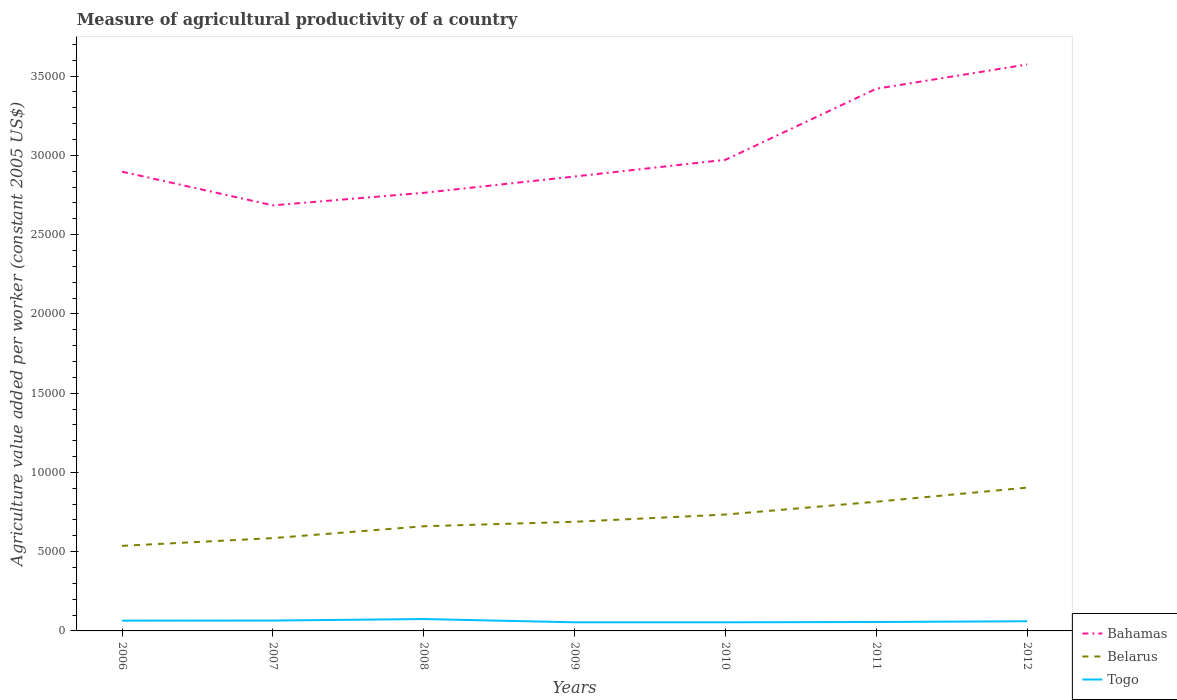Does the line corresponding to Belarus intersect with the line corresponding to Bahamas?
Make the answer very short. No. Is the number of lines equal to the number of legend labels?
Offer a terse response. Yes. Across all years, what is the maximum measure of agricultural productivity in Togo?
Make the answer very short. 543.73. What is the total measure of agricultural productivity in Togo in the graph?
Ensure brevity in your answer.  -0.05. What is the difference between the highest and the second highest measure of agricultural productivity in Togo?
Give a very brief answer. 205.68. What is the difference between the highest and the lowest measure of agricultural productivity in Belarus?
Your answer should be compact. 3. Is the measure of agricultural productivity in Bahamas strictly greater than the measure of agricultural productivity in Togo over the years?
Keep it short and to the point. No. What is the difference between two consecutive major ticks on the Y-axis?
Offer a very short reply. 5000. Does the graph contain any zero values?
Offer a terse response. No. What is the title of the graph?
Provide a short and direct response. Measure of agricultural productivity of a country. Does "Papua New Guinea" appear as one of the legend labels in the graph?
Keep it short and to the point. No. What is the label or title of the Y-axis?
Your response must be concise. Agriculture value added per worker (constant 2005 US$). What is the Agriculture value added per worker (constant 2005 US$) in Bahamas in 2006?
Provide a short and direct response. 2.90e+04. What is the Agriculture value added per worker (constant 2005 US$) in Belarus in 2006?
Your answer should be compact. 5366.93. What is the Agriculture value added per worker (constant 2005 US$) in Togo in 2006?
Give a very brief answer. 648.93. What is the Agriculture value added per worker (constant 2005 US$) in Bahamas in 2007?
Ensure brevity in your answer.  2.68e+04. What is the Agriculture value added per worker (constant 2005 US$) in Belarus in 2007?
Provide a succinct answer. 5855.35. What is the Agriculture value added per worker (constant 2005 US$) in Togo in 2007?
Provide a short and direct response. 654.09. What is the Agriculture value added per worker (constant 2005 US$) in Bahamas in 2008?
Give a very brief answer. 2.76e+04. What is the Agriculture value added per worker (constant 2005 US$) of Belarus in 2008?
Offer a very short reply. 6602.84. What is the Agriculture value added per worker (constant 2005 US$) in Togo in 2008?
Your answer should be compact. 749.41. What is the Agriculture value added per worker (constant 2005 US$) in Bahamas in 2009?
Ensure brevity in your answer.  2.87e+04. What is the Agriculture value added per worker (constant 2005 US$) in Belarus in 2009?
Your answer should be very brief. 6885.24. What is the Agriculture value added per worker (constant 2005 US$) in Togo in 2009?
Make the answer very short. 543.73. What is the Agriculture value added per worker (constant 2005 US$) of Bahamas in 2010?
Offer a very short reply. 2.97e+04. What is the Agriculture value added per worker (constant 2005 US$) of Belarus in 2010?
Your response must be concise. 7341.49. What is the Agriculture value added per worker (constant 2005 US$) in Togo in 2010?
Offer a very short reply. 543.78. What is the Agriculture value added per worker (constant 2005 US$) in Bahamas in 2011?
Your answer should be compact. 3.42e+04. What is the Agriculture value added per worker (constant 2005 US$) in Belarus in 2011?
Offer a terse response. 8150.77. What is the Agriculture value added per worker (constant 2005 US$) in Togo in 2011?
Offer a terse response. 562.64. What is the Agriculture value added per worker (constant 2005 US$) of Bahamas in 2012?
Your answer should be compact. 3.57e+04. What is the Agriculture value added per worker (constant 2005 US$) of Belarus in 2012?
Provide a short and direct response. 9040.6. What is the Agriculture value added per worker (constant 2005 US$) of Togo in 2012?
Keep it short and to the point. 610.53. Across all years, what is the maximum Agriculture value added per worker (constant 2005 US$) in Bahamas?
Your response must be concise. 3.57e+04. Across all years, what is the maximum Agriculture value added per worker (constant 2005 US$) in Belarus?
Give a very brief answer. 9040.6. Across all years, what is the maximum Agriculture value added per worker (constant 2005 US$) in Togo?
Your answer should be compact. 749.41. Across all years, what is the minimum Agriculture value added per worker (constant 2005 US$) in Bahamas?
Your answer should be very brief. 2.68e+04. Across all years, what is the minimum Agriculture value added per worker (constant 2005 US$) in Belarus?
Your response must be concise. 5366.93. Across all years, what is the minimum Agriculture value added per worker (constant 2005 US$) of Togo?
Ensure brevity in your answer.  543.73. What is the total Agriculture value added per worker (constant 2005 US$) of Bahamas in the graph?
Your answer should be compact. 2.12e+05. What is the total Agriculture value added per worker (constant 2005 US$) in Belarus in the graph?
Give a very brief answer. 4.92e+04. What is the total Agriculture value added per worker (constant 2005 US$) of Togo in the graph?
Provide a short and direct response. 4313.11. What is the difference between the Agriculture value added per worker (constant 2005 US$) of Bahamas in 2006 and that in 2007?
Offer a terse response. 2124.79. What is the difference between the Agriculture value added per worker (constant 2005 US$) of Belarus in 2006 and that in 2007?
Make the answer very short. -488.42. What is the difference between the Agriculture value added per worker (constant 2005 US$) of Togo in 2006 and that in 2007?
Provide a short and direct response. -5.15. What is the difference between the Agriculture value added per worker (constant 2005 US$) of Bahamas in 2006 and that in 2008?
Give a very brief answer. 1333.73. What is the difference between the Agriculture value added per worker (constant 2005 US$) of Belarus in 2006 and that in 2008?
Your answer should be compact. -1235.91. What is the difference between the Agriculture value added per worker (constant 2005 US$) of Togo in 2006 and that in 2008?
Your answer should be very brief. -100.47. What is the difference between the Agriculture value added per worker (constant 2005 US$) in Bahamas in 2006 and that in 2009?
Ensure brevity in your answer.  303.45. What is the difference between the Agriculture value added per worker (constant 2005 US$) of Belarus in 2006 and that in 2009?
Keep it short and to the point. -1518.31. What is the difference between the Agriculture value added per worker (constant 2005 US$) in Togo in 2006 and that in 2009?
Your response must be concise. 105.21. What is the difference between the Agriculture value added per worker (constant 2005 US$) of Bahamas in 2006 and that in 2010?
Give a very brief answer. -749.95. What is the difference between the Agriculture value added per worker (constant 2005 US$) in Belarus in 2006 and that in 2010?
Provide a short and direct response. -1974.57. What is the difference between the Agriculture value added per worker (constant 2005 US$) of Togo in 2006 and that in 2010?
Your answer should be compact. 105.15. What is the difference between the Agriculture value added per worker (constant 2005 US$) in Bahamas in 2006 and that in 2011?
Your response must be concise. -5231.33. What is the difference between the Agriculture value added per worker (constant 2005 US$) in Belarus in 2006 and that in 2011?
Make the answer very short. -2783.84. What is the difference between the Agriculture value added per worker (constant 2005 US$) in Togo in 2006 and that in 2011?
Your response must be concise. 86.29. What is the difference between the Agriculture value added per worker (constant 2005 US$) in Bahamas in 2006 and that in 2012?
Your answer should be very brief. -6763.83. What is the difference between the Agriculture value added per worker (constant 2005 US$) of Belarus in 2006 and that in 2012?
Your answer should be compact. -3673.67. What is the difference between the Agriculture value added per worker (constant 2005 US$) of Togo in 2006 and that in 2012?
Provide a succinct answer. 38.4. What is the difference between the Agriculture value added per worker (constant 2005 US$) in Bahamas in 2007 and that in 2008?
Provide a short and direct response. -791.06. What is the difference between the Agriculture value added per worker (constant 2005 US$) of Belarus in 2007 and that in 2008?
Make the answer very short. -747.49. What is the difference between the Agriculture value added per worker (constant 2005 US$) of Togo in 2007 and that in 2008?
Offer a terse response. -95.32. What is the difference between the Agriculture value added per worker (constant 2005 US$) of Bahamas in 2007 and that in 2009?
Keep it short and to the point. -1821.34. What is the difference between the Agriculture value added per worker (constant 2005 US$) in Belarus in 2007 and that in 2009?
Your response must be concise. -1029.89. What is the difference between the Agriculture value added per worker (constant 2005 US$) of Togo in 2007 and that in 2009?
Provide a succinct answer. 110.36. What is the difference between the Agriculture value added per worker (constant 2005 US$) of Bahamas in 2007 and that in 2010?
Your response must be concise. -2874.74. What is the difference between the Agriculture value added per worker (constant 2005 US$) in Belarus in 2007 and that in 2010?
Keep it short and to the point. -1486.14. What is the difference between the Agriculture value added per worker (constant 2005 US$) of Togo in 2007 and that in 2010?
Offer a very short reply. 110.3. What is the difference between the Agriculture value added per worker (constant 2005 US$) in Bahamas in 2007 and that in 2011?
Keep it short and to the point. -7356.12. What is the difference between the Agriculture value added per worker (constant 2005 US$) of Belarus in 2007 and that in 2011?
Keep it short and to the point. -2295.42. What is the difference between the Agriculture value added per worker (constant 2005 US$) in Togo in 2007 and that in 2011?
Keep it short and to the point. 91.44. What is the difference between the Agriculture value added per worker (constant 2005 US$) in Bahamas in 2007 and that in 2012?
Make the answer very short. -8888.62. What is the difference between the Agriculture value added per worker (constant 2005 US$) in Belarus in 2007 and that in 2012?
Your answer should be compact. -3185.25. What is the difference between the Agriculture value added per worker (constant 2005 US$) in Togo in 2007 and that in 2012?
Keep it short and to the point. 43.55. What is the difference between the Agriculture value added per worker (constant 2005 US$) of Bahamas in 2008 and that in 2009?
Ensure brevity in your answer.  -1030.28. What is the difference between the Agriculture value added per worker (constant 2005 US$) in Belarus in 2008 and that in 2009?
Offer a terse response. -282.4. What is the difference between the Agriculture value added per worker (constant 2005 US$) in Togo in 2008 and that in 2009?
Make the answer very short. 205.68. What is the difference between the Agriculture value added per worker (constant 2005 US$) in Bahamas in 2008 and that in 2010?
Your answer should be very brief. -2083.69. What is the difference between the Agriculture value added per worker (constant 2005 US$) in Belarus in 2008 and that in 2010?
Your answer should be compact. -738.65. What is the difference between the Agriculture value added per worker (constant 2005 US$) in Togo in 2008 and that in 2010?
Provide a succinct answer. 205.63. What is the difference between the Agriculture value added per worker (constant 2005 US$) of Bahamas in 2008 and that in 2011?
Your response must be concise. -6565.06. What is the difference between the Agriculture value added per worker (constant 2005 US$) in Belarus in 2008 and that in 2011?
Make the answer very short. -1547.93. What is the difference between the Agriculture value added per worker (constant 2005 US$) of Togo in 2008 and that in 2011?
Offer a very short reply. 186.76. What is the difference between the Agriculture value added per worker (constant 2005 US$) of Bahamas in 2008 and that in 2012?
Your answer should be compact. -8097.56. What is the difference between the Agriculture value added per worker (constant 2005 US$) in Belarus in 2008 and that in 2012?
Offer a terse response. -2437.76. What is the difference between the Agriculture value added per worker (constant 2005 US$) of Togo in 2008 and that in 2012?
Provide a short and direct response. 138.88. What is the difference between the Agriculture value added per worker (constant 2005 US$) in Bahamas in 2009 and that in 2010?
Offer a terse response. -1053.4. What is the difference between the Agriculture value added per worker (constant 2005 US$) of Belarus in 2009 and that in 2010?
Your answer should be compact. -456.25. What is the difference between the Agriculture value added per worker (constant 2005 US$) of Togo in 2009 and that in 2010?
Your answer should be compact. -0.06. What is the difference between the Agriculture value added per worker (constant 2005 US$) of Bahamas in 2009 and that in 2011?
Your response must be concise. -5534.78. What is the difference between the Agriculture value added per worker (constant 2005 US$) of Belarus in 2009 and that in 2011?
Your response must be concise. -1265.53. What is the difference between the Agriculture value added per worker (constant 2005 US$) of Togo in 2009 and that in 2011?
Give a very brief answer. -18.92. What is the difference between the Agriculture value added per worker (constant 2005 US$) of Bahamas in 2009 and that in 2012?
Your answer should be very brief. -7067.28. What is the difference between the Agriculture value added per worker (constant 2005 US$) in Belarus in 2009 and that in 2012?
Your answer should be very brief. -2155.36. What is the difference between the Agriculture value added per worker (constant 2005 US$) of Togo in 2009 and that in 2012?
Ensure brevity in your answer.  -66.8. What is the difference between the Agriculture value added per worker (constant 2005 US$) of Bahamas in 2010 and that in 2011?
Provide a succinct answer. -4481.38. What is the difference between the Agriculture value added per worker (constant 2005 US$) of Belarus in 2010 and that in 2011?
Provide a short and direct response. -809.28. What is the difference between the Agriculture value added per worker (constant 2005 US$) of Togo in 2010 and that in 2011?
Give a very brief answer. -18.86. What is the difference between the Agriculture value added per worker (constant 2005 US$) in Bahamas in 2010 and that in 2012?
Provide a short and direct response. -6013.88. What is the difference between the Agriculture value added per worker (constant 2005 US$) of Belarus in 2010 and that in 2012?
Your answer should be compact. -1699.11. What is the difference between the Agriculture value added per worker (constant 2005 US$) of Togo in 2010 and that in 2012?
Your answer should be compact. -66.75. What is the difference between the Agriculture value added per worker (constant 2005 US$) of Bahamas in 2011 and that in 2012?
Your answer should be compact. -1532.5. What is the difference between the Agriculture value added per worker (constant 2005 US$) of Belarus in 2011 and that in 2012?
Offer a terse response. -889.83. What is the difference between the Agriculture value added per worker (constant 2005 US$) of Togo in 2011 and that in 2012?
Your answer should be very brief. -47.89. What is the difference between the Agriculture value added per worker (constant 2005 US$) in Bahamas in 2006 and the Agriculture value added per worker (constant 2005 US$) in Belarus in 2007?
Offer a terse response. 2.31e+04. What is the difference between the Agriculture value added per worker (constant 2005 US$) in Bahamas in 2006 and the Agriculture value added per worker (constant 2005 US$) in Togo in 2007?
Keep it short and to the point. 2.83e+04. What is the difference between the Agriculture value added per worker (constant 2005 US$) in Belarus in 2006 and the Agriculture value added per worker (constant 2005 US$) in Togo in 2007?
Offer a very short reply. 4712.84. What is the difference between the Agriculture value added per worker (constant 2005 US$) of Bahamas in 2006 and the Agriculture value added per worker (constant 2005 US$) of Belarus in 2008?
Your answer should be very brief. 2.24e+04. What is the difference between the Agriculture value added per worker (constant 2005 US$) in Bahamas in 2006 and the Agriculture value added per worker (constant 2005 US$) in Togo in 2008?
Keep it short and to the point. 2.82e+04. What is the difference between the Agriculture value added per worker (constant 2005 US$) in Belarus in 2006 and the Agriculture value added per worker (constant 2005 US$) in Togo in 2008?
Offer a terse response. 4617.52. What is the difference between the Agriculture value added per worker (constant 2005 US$) of Bahamas in 2006 and the Agriculture value added per worker (constant 2005 US$) of Belarus in 2009?
Offer a terse response. 2.21e+04. What is the difference between the Agriculture value added per worker (constant 2005 US$) of Bahamas in 2006 and the Agriculture value added per worker (constant 2005 US$) of Togo in 2009?
Provide a short and direct response. 2.84e+04. What is the difference between the Agriculture value added per worker (constant 2005 US$) of Belarus in 2006 and the Agriculture value added per worker (constant 2005 US$) of Togo in 2009?
Your response must be concise. 4823.2. What is the difference between the Agriculture value added per worker (constant 2005 US$) in Bahamas in 2006 and the Agriculture value added per worker (constant 2005 US$) in Belarus in 2010?
Make the answer very short. 2.16e+04. What is the difference between the Agriculture value added per worker (constant 2005 US$) of Bahamas in 2006 and the Agriculture value added per worker (constant 2005 US$) of Togo in 2010?
Provide a succinct answer. 2.84e+04. What is the difference between the Agriculture value added per worker (constant 2005 US$) of Belarus in 2006 and the Agriculture value added per worker (constant 2005 US$) of Togo in 2010?
Your answer should be compact. 4823.15. What is the difference between the Agriculture value added per worker (constant 2005 US$) of Bahamas in 2006 and the Agriculture value added per worker (constant 2005 US$) of Belarus in 2011?
Offer a very short reply. 2.08e+04. What is the difference between the Agriculture value added per worker (constant 2005 US$) in Bahamas in 2006 and the Agriculture value added per worker (constant 2005 US$) in Togo in 2011?
Offer a terse response. 2.84e+04. What is the difference between the Agriculture value added per worker (constant 2005 US$) in Belarus in 2006 and the Agriculture value added per worker (constant 2005 US$) in Togo in 2011?
Make the answer very short. 4804.28. What is the difference between the Agriculture value added per worker (constant 2005 US$) in Bahamas in 2006 and the Agriculture value added per worker (constant 2005 US$) in Belarus in 2012?
Ensure brevity in your answer.  1.99e+04. What is the difference between the Agriculture value added per worker (constant 2005 US$) in Bahamas in 2006 and the Agriculture value added per worker (constant 2005 US$) in Togo in 2012?
Ensure brevity in your answer.  2.84e+04. What is the difference between the Agriculture value added per worker (constant 2005 US$) of Belarus in 2006 and the Agriculture value added per worker (constant 2005 US$) of Togo in 2012?
Provide a short and direct response. 4756.4. What is the difference between the Agriculture value added per worker (constant 2005 US$) in Bahamas in 2007 and the Agriculture value added per worker (constant 2005 US$) in Belarus in 2008?
Offer a very short reply. 2.02e+04. What is the difference between the Agriculture value added per worker (constant 2005 US$) of Bahamas in 2007 and the Agriculture value added per worker (constant 2005 US$) of Togo in 2008?
Ensure brevity in your answer.  2.61e+04. What is the difference between the Agriculture value added per worker (constant 2005 US$) of Belarus in 2007 and the Agriculture value added per worker (constant 2005 US$) of Togo in 2008?
Your answer should be compact. 5105.94. What is the difference between the Agriculture value added per worker (constant 2005 US$) of Bahamas in 2007 and the Agriculture value added per worker (constant 2005 US$) of Belarus in 2009?
Ensure brevity in your answer.  2.00e+04. What is the difference between the Agriculture value added per worker (constant 2005 US$) in Bahamas in 2007 and the Agriculture value added per worker (constant 2005 US$) in Togo in 2009?
Your answer should be very brief. 2.63e+04. What is the difference between the Agriculture value added per worker (constant 2005 US$) of Belarus in 2007 and the Agriculture value added per worker (constant 2005 US$) of Togo in 2009?
Your answer should be compact. 5311.62. What is the difference between the Agriculture value added per worker (constant 2005 US$) of Bahamas in 2007 and the Agriculture value added per worker (constant 2005 US$) of Belarus in 2010?
Provide a short and direct response. 1.95e+04. What is the difference between the Agriculture value added per worker (constant 2005 US$) in Bahamas in 2007 and the Agriculture value added per worker (constant 2005 US$) in Togo in 2010?
Keep it short and to the point. 2.63e+04. What is the difference between the Agriculture value added per worker (constant 2005 US$) of Belarus in 2007 and the Agriculture value added per worker (constant 2005 US$) of Togo in 2010?
Give a very brief answer. 5311.57. What is the difference between the Agriculture value added per worker (constant 2005 US$) in Bahamas in 2007 and the Agriculture value added per worker (constant 2005 US$) in Belarus in 2011?
Your response must be concise. 1.87e+04. What is the difference between the Agriculture value added per worker (constant 2005 US$) of Bahamas in 2007 and the Agriculture value added per worker (constant 2005 US$) of Togo in 2011?
Ensure brevity in your answer.  2.63e+04. What is the difference between the Agriculture value added per worker (constant 2005 US$) of Belarus in 2007 and the Agriculture value added per worker (constant 2005 US$) of Togo in 2011?
Provide a succinct answer. 5292.7. What is the difference between the Agriculture value added per worker (constant 2005 US$) in Bahamas in 2007 and the Agriculture value added per worker (constant 2005 US$) in Belarus in 2012?
Offer a very short reply. 1.78e+04. What is the difference between the Agriculture value added per worker (constant 2005 US$) of Bahamas in 2007 and the Agriculture value added per worker (constant 2005 US$) of Togo in 2012?
Provide a succinct answer. 2.62e+04. What is the difference between the Agriculture value added per worker (constant 2005 US$) of Belarus in 2007 and the Agriculture value added per worker (constant 2005 US$) of Togo in 2012?
Provide a short and direct response. 5244.82. What is the difference between the Agriculture value added per worker (constant 2005 US$) in Bahamas in 2008 and the Agriculture value added per worker (constant 2005 US$) in Belarus in 2009?
Your response must be concise. 2.08e+04. What is the difference between the Agriculture value added per worker (constant 2005 US$) of Bahamas in 2008 and the Agriculture value added per worker (constant 2005 US$) of Togo in 2009?
Your response must be concise. 2.71e+04. What is the difference between the Agriculture value added per worker (constant 2005 US$) in Belarus in 2008 and the Agriculture value added per worker (constant 2005 US$) in Togo in 2009?
Offer a very short reply. 6059.11. What is the difference between the Agriculture value added per worker (constant 2005 US$) in Bahamas in 2008 and the Agriculture value added per worker (constant 2005 US$) in Belarus in 2010?
Your answer should be compact. 2.03e+04. What is the difference between the Agriculture value added per worker (constant 2005 US$) of Bahamas in 2008 and the Agriculture value added per worker (constant 2005 US$) of Togo in 2010?
Offer a very short reply. 2.71e+04. What is the difference between the Agriculture value added per worker (constant 2005 US$) in Belarus in 2008 and the Agriculture value added per worker (constant 2005 US$) in Togo in 2010?
Provide a succinct answer. 6059.06. What is the difference between the Agriculture value added per worker (constant 2005 US$) of Bahamas in 2008 and the Agriculture value added per worker (constant 2005 US$) of Belarus in 2011?
Your answer should be very brief. 1.95e+04. What is the difference between the Agriculture value added per worker (constant 2005 US$) of Bahamas in 2008 and the Agriculture value added per worker (constant 2005 US$) of Togo in 2011?
Your response must be concise. 2.71e+04. What is the difference between the Agriculture value added per worker (constant 2005 US$) of Belarus in 2008 and the Agriculture value added per worker (constant 2005 US$) of Togo in 2011?
Your answer should be very brief. 6040.2. What is the difference between the Agriculture value added per worker (constant 2005 US$) in Bahamas in 2008 and the Agriculture value added per worker (constant 2005 US$) in Belarus in 2012?
Ensure brevity in your answer.  1.86e+04. What is the difference between the Agriculture value added per worker (constant 2005 US$) in Bahamas in 2008 and the Agriculture value added per worker (constant 2005 US$) in Togo in 2012?
Provide a short and direct response. 2.70e+04. What is the difference between the Agriculture value added per worker (constant 2005 US$) in Belarus in 2008 and the Agriculture value added per worker (constant 2005 US$) in Togo in 2012?
Offer a terse response. 5992.31. What is the difference between the Agriculture value added per worker (constant 2005 US$) in Bahamas in 2009 and the Agriculture value added per worker (constant 2005 US$) in Belarus in 2010?
Your answer should be compact. 2.13e+04. What is the difference between the Agriculture value added per worker (constant 2005 US$) in Bahamas in 2009 and the Agriculture value added per worker (constant 2005 US$) in Togo in 2010?
Ensure brevity in your answer.  2.81e+04. What is the difference between the Agriculture value added per worker (constant 2005 US$) in Belarus in 2009 and the Agriculture value added per worker (constant 2005 US$) in Togo in 2010?
Your answer should be very brief. 6341.46. What is the difference between the Agriculture value added per worker (constant 2005 US$) in Bahamas in 2009 and the Agriculture value added per worker (constant 2005 US$) in Belarus in 2011?
Give a very brief answer. 2.05e+04. What is the difference between the Agriculture value added per worker (constant 2005 US$) of Bahamas in 2009 and the Agriculture value added per worker (constant 2005 US$) of Togo in 2011?
Keep it short and to the point. 2.81e+04. What is the difference between the Agriculture value added per worker (constant 2005 US$) of Belarus in 2009 and the Agriculture value added per worker (constant 2005 US$) of Togo in 2011?
Offer a terse response. 6322.6. What is the difference between the Agriculture value added per worker (constant 2005 US$) in Bahamas in 2009 and the Agriculture value added per worker (constant 2005 US$) in Belarus in 2012?
Ensure brevity in your answer.  1.96e+04. What is the difference between the Agriculture value added per worker (constant 2005 US$) in Bahamas in 2009 and the Agriculture value added per worker (constant 2005 US$) in Togo in 2012?
Offer a very short reply. 2.81e+04. What is the difference between the Agriculture value added per worker (constant 2005 US$) in Belarus in 2009 and the Agriculture value added per worker (constant 2005 US$) in Togo in 2012?
Your answer should be compact. 6274.71. What is the difference between the Agriculture value added per worker (constant 2005 US$) of Bahamas in 2010 and the Agriculture value added per worker (constant 2005 US$) of Belarus in 2011?
Make the answer very short. 2.16e+04. What is the difference between the Agriculture value added per worker (constant 2005 US$) of Bahamas in 2010 and the Agriculture value added per worker (constant 2005 US$) of Togo in 2011?
Provide a succinct answer. 2.92e+04. What is the difference between the Agriculture value added per worker (constant 2005 US$) in Belarus in 2010 and the Agriculture value added per worker (constant 2005 US$) in Togo in 2011?
Offer a very short reply. 6778.85. What is the difference between the Agriculture value added per worker (constant 2005 US$) of Bahamas in 2010 and the Agriculture value added per worker (constant 2005 US$) of Belarus in 2012?
Your answer should be very brief. 2.07e+04. What is the difference between the Agriculture value added per worker (constant 2005 US$) in Bahamas in 2010 and the Agriculture value added per worker (constant 2005 US$) in Togo in 2012?
Your answer should be compact. 2.91e+04. What is the difference between the Agriculture value added per worker (constant 2005 US$) of Belarus in 2010 and the Agriculture value added per worker (constant 2005 US$) of Togo in 2012?
Offer a terse response. 6730.96. What is the difference between the Agriculture value added per worker (constant 2005 US$) of Bahamas in 2011 and the Agriculture value added per worker (constant 2005 US$) of Belarus in 2012?
Make the answer very short. 2.52e+04. What is the difference between the Agriculture value added per worker (constant 2005 US$) of Bahamas in 2011 and the Agriculture value added per worker (constant 2005 US$) of Togo in 2012?
Keep it short and to the point. 3.36e+04. What is the difference between the Agriculture value added per worker (constant 2005 US$) in Belarus in 2011 and the Agriculture value added per worker (constant 2005 US$) in Togo in 2012?
Your answer should be compact. 7540.24. What is the average Agriculture value added per worker (constant 2005 US$) in Bahamas per year?
Provide a succinct answer. 3.03e+04. What is the average Agriculture value added per worker (constant 2005 US$) in Belarus per year?
Your response must be concise. 7034.74. What is the average Agriculture value added per worker (constant 2005 US$) of Togo per year?
Ensure brevity in your answer.  616.16. In the year 2006, what is the difference between the Agriculture value added per worker (constant 2005 US$) in Bahamas and Agriculture value added per worker (constant 2005 US$) in Belarus?
Provide a short and direct response. 2.36e+04. In the year 2006, what is the difference between the Agriculture value added per worker (constant 2005 US$) in Bahamas and Agriculture value added per worker (constant 2005 US$) in Togo?
Provide a short and direct response. 2.83e+04. In the year 2006, what is the difference between the Agriculture value added per worker (constant 2005 US$) in Belarus and Agriculture value added per worker (constant 2005 US$) in Togo?
Ensure brevity in your answer.  4717.99. In the year 2007, what is the difference between the Agriculture value added per worker (constant 2005 US$) of Bahamas and Agriculture value added per worker (constant 2005 US$) of Belarus?
Offer a very short reply. 2.10e+04. In the year 2007, what is the difference between the Agriculture value added per worker (constant 2005 US$) of Bahamas and Agriculture value added per worker (constant 2005 US$) of Togo?
Give a very brief answer. 2.62e+04. In the year 2007, what is the difference between the Agriculture value added per worker (constant 2005 US$) of Belarus and Agriculture value added per worker (constant 2005 US$) of Togo?
Give a very brief answer. 5201.26. In the year 2008, what is the difference between the Agriculture value added per worker (constant 2005 US$) of Bahamas and Agriculture value added per worker (constant 2005 US$) of Belarus?
Offer a very short reply. 2.10e+04. In the year 2008, what is the difference between the Agriculture value added per worker (constant 2005 US$) in Bahamas and Agriculture value added per worker (constant 2005 US$) in Togo?
Your answer should be very brief. 2.69e+04. In the year 2008, what is the difference between the Agriculture value added per worker (constant 2005 US$) in Belarus and Agriculture value added per worker (constant 2005 US$) in Togo?
Make the answer very short. 5853.43. In the year 2009, what is the difference between the Agriculture value added per worker (constant 2005 US$) of Bahamas and Agriculture value added per worker (constant 2005 US$) of Belarus?
Make the answer very short. 2.18e+04. In the year 2009, what is the difference between the Agriculture value added per worker (constant 2005 US$) in Bahamas and Agriculture value added per worker (constant 2005 US$) in Togo?
Your answer should be very brief. 2.81e+04. In the year 2009, what is the difference between the Agriculture value added per worker (constant 2005 US$) in Belarus and Agriculture value added per worker (constant 2005 US$) in Togo?
Offer a very short reply. 6341.51. In the year 2010, what is the difference between the Agriculture value added per worker (constant 2005 US$) in Bahamas and Agriculture value added per worker (constant 2005 US$) in Belarus?
Give a very brief answer. 2.24e+04. In the year 2010, what is the difference between the Agriculture value added per worker (constant 2005 US$) in Bahamas and Agriculture value added per worker (constant 2005 US$) in Togo?
Offer a very short reply. 2.92e+04. In the year 2010, what is the difference between the Agriculture value added per worker (constant 2005 US$) of Belarus and Agriculture value added per worker (constant 2005 US$) of Togo?
Provide a succinct answer. 6797.71. In the year 2011, what is the difference between the Agriculture value added per worker (constant 2005 US$) in Bahamas and Agriculture value added per worker (constant 2005 US$) in Belarus?
Make the answer very short. 2.61e+04. In the year 2011, what is the difference between the Agriculture value added per worker (constant 2005 US$) in Bahamas and Agriculture value added per worker (constant 2005 US$) in Togo?
Give a very brief answer. 3.36e+04. In the year 2011, what is the difference between the Agriculture value added per worker (constant 2005 US$) of Belarus and Agriculture value added per worker (constant 2005 US$) of Togo?
Offer a terse response. 7588.12. In the year 2012, what is the difference between the Agriculture value added per worker (constant 2005 US$) of Bahamas and Agriculture value added per worker (constant 2005 US$) of Belarus?
Give a very brief answer. 2.67e+04. In the year 2012, what is the difference between the Agriculture value added per worker (constant 2005 US$) in Bahamas and Agriculture value added per worker (constant 2005 US$) in Togo?
Provide a short and direct response. 3.51e+04. In the year 2012, what is the difference between the Agriculture value added per worker (constant 2005 US$) in Belarus and Agriculture value added per worker (constant 2005 US$) in Togo?
Make the answer very short. 8430.07. What is the ratio of the Agriculture value added per worker (constant 2005 US$) in Bahamas in 2006 to that in 2007?
Provide a succinct answer. 1.08. What is the ratio of the Agriculture value added per worker (constant 2005 US$) of Belarus in 2006 to that in 2007?
Keep it short and to the point. 0.92. What is the ratio of the Agriculture value added per worker (constant 2005 US$) of Bahamas in 2006 to that in 2008?
Provide a succinct answer. 1.05. What is the ratio of the Agriculture value added per worker (constant 2005 US$) in Belarus in 2006 to that in 2008?
Make the answer very short. 0.81. What is the ratio of the Agriculture value added per worker (constant 2005 US$) of Togo in 2006 to that in 2008?
Provide a short and direct response. 0.87. What is the ratio of the Agriculture value added per worker (constant 2005 US$) in Bahamas in 2006 to that in 2009?
Ensure brevity in your answer.  1.01. What is the ratio of the Agriculture value added per worker (constant 2005 US$) in Belarus in 2006 to that in 2009?
Give a very brief answer. 0.78. What is the ratio of the Agriculture value added per worker (constant 2005 US$) in Togo in 2006 to that in 2009?
Ensure brevity in your answer.  1.19. What is the ratio of the Agriculture value added per worker (constant 2005 US$) in Bahamas in 2006 to that in 2010?
Provide a short and direct response. 0.97. What is the ratio of the Agriculture value added per worker (constant 2005 US$) of Belarus in 2006 to that in 2010?
Your answer should be very brief. 0.73. What is the ratio of the Agriculture value added per worker (constant 2005 US$) in Togo in 2006 to that in 2010?
Make the answer very short. 1.19. What is the ratio of the Agriculture value added per worker (constant 2005 US$) in Bahamas in 2006 to that in 2011?
Keep it short and to the point. 0.85. What is the ratio of the Agriculture value added per worker (constant 2005 US$) in Belarus in 2006 to that in 2011?
Offer a terse response. 0.66. What is the ratio of the Agriculture value added per worker (constant 2005 US$) in Togo in 2006 to that in 2011?
Give a very brief answer. 1.15. What is the ratio of the Agriculture value added per worker (constant 2005 US$) in Bahamas in 2006 to that in 2012?
Your answer should be compact. 0.81. What is the ratio of the Agriculture value added per worker (constant 2005 US$) in Belarus in 2006 to that in 2012?
Your answer should be very brief. 0.59. What is the ratio of the Agriculture value added per worker (constant 2005 US$) of Togo in 2006 to that in 2012?
Offer a terse response. 1.06. What is the ratio of the Agriculture value added per worker (constant 2005 US$) of Bahamas in 2007 to that in 2008?
Keep it short and to the point. 0.97. What is the ratio of the Agriculture value added per worker (constant 2005 US$) of Belarus in 2007 to that in 2008?
Your answer should be very brief. 0.89. What is the ratio of the Agriculture value added per worker (constant 2005 US$) in Togo in 2007 to that in 2008?
Offer a very short reply. 0.87. What is the ratio of the Agriculture value added per worker (constant 2005 US$) of Bahamas in 2007 to that in 2009?
Your answer should be very brief. 0.94. What is the ratio of the Agriculture value added per worker (constant 2005 US$) in Belarus in 2007 to that in 2009?
Keep it short and to the point. 0.85. What is the ratio of the Agriculture value added per worker (constant 2005 US$) of Togo in 2007 to that in 2009?
Provide a succinct answer. 1.2. What is the ratio of the Agriculture value added per worker (constant 2005 US$) of Bahamas in 2007 to that in 2010?
Provide a succinct answer. 0.9. What is the ratio of the Agriculture value added per worker (constant 2005 US$) of Belarus in 2007 to that in 2010?
Offer a terse response. 0.8. What is the ratio of the Agriculture value added per worker (constant 2005 US$) in Togo in 2007 to that in 2010?
Keep it short and to the point. 1.2. What is the ratio of the Agriculture value added per worker (constant 2005 US$) of Bahamas in 2007 to that in 2011?
Offer a terse response. 0.78. What is the ratio of the Agriculture value added per worker (constant 2005 US$) of Belarus in 2007 to that in 2011?
Give a very brief answer. 0.72. What is the ratio of the Agriculture value added per worker (constant 2005 US$) in Togo in 2007 to that in 2011?
Provide a succinct answer. 1.16. What is the ratio of the Agriculture value added per worker (constant 2005 US$) in Bahamas in 2007 to that in 2012?
Make the answer very short. 0.75. What is the ratio of the Agriculture value added per worker (constant 2005 US$) in Belarus in 2007 to that in 2012?
Your answer should be compact. 0.65. What is the ratio of the Agriculture value added per worker (constant 2005 US$) of Togo in 2007 to that in 2012?
Offer a terse response. 1.07. What is the ratio of the Agriculture value added per worker (constant 2005 US$) in Bahamas in 2008 to that in 2009?
Provide a succinct answer. 0.96. What is the ratio of the Agriculture value added per worker (constant 2005 US$) of Togo in 2008 to that in 2009?
Offer a very short reply. 1.38. What is the ratio of the Agriculture value added per worker (constant 2005 US$) in Bahamas in 2008 to that in 2010?
Provide a succinct answer. 0.93. What is the ratio of the Agriculture value added per worker (constant 2005 US$) in Belarus in 2008 to that in 2010?
Make the answer very short. 0.9. What is the ratio of the Agriculture value added per worker (constant 2005 US$) of Togo in 2008 to that in 2010?
Make the answer very short. 1.38. What is the ratio of the Agriculture value added per worker (constant 2005 US$) in Bahamas in 2008 to that in 2011?
Offer a very short reply. 0.81. What is the ratio of the Agriculture value added per worker (constant 2005 US$) in Belarus in 2008 to that in 2011?
Your answer should be compact. 0.81. What is the ratio of the Agriculture value added per worker (constant 2005 US$) in Togo in 2008 to that in 2011?
Offer a very short reply. 1.33. What is the ratio of the Agriculture value added per worker (constant 2005 US$) in Bahamas in 2008 to that in 2012?
Your response must be concise. 0.77. What is the ratio of the Agriculture value added per worker (constant 2005 US$) of Belarus in 2008 to that in 2012?
Make the answer very short. 0.73. What is the ratio of the Agriculture value added per worker (constant 2005 US$) of Togo in 2008 to that in 2012?
Provide a succinct answer. 1.23. What is the ratio of the Agriculture value added per worker (constant 2005 US$) of Bahamas in 2009 to that in 2010?
Make the answer very short. 0.96. What is the ratio of the Agriculture value added per worker (constant 2005 US$) of Belarus in 2009 to that in 2010?
Your answer should be very brief. 0.94. What is the ratio of the Agriculture value added per worker (constant 2005 US$) in Togo in 2009 to that in 2010?
Give a very brief answer. 1. What is the ratio of the Agriculture value added per worker (constant 2005 US$) of Bahamas in 2009 to that in 2011?
Ensure brevity in your answer.  0.84. What is the ratio of the Agriculture value added per worker (constant 2005 US$) in Belarus in 2009 to that in 2011?
Provide a short and direct response. 0.84. What is the ratio of the Agriculture value added per worker (constant 2005 US$) in Togo in 2009 to that in 2011?
Offer a terse response. 0.97. What is the ratio of the Agriculture value added per worker (constant 2005 US$) of Bahamas in 2009 to that in 2012?
Your response must be concise. 0.8. What is the ratio of the Agriculture value added per worker (constant 2005 US$) in Belarus in 2009 to that in 2012?
Provide a short and direct response. 0.76. What is the ratio of the Agriculture value added per worker (constant 2005 US$) in Togo in 2009 to that in 2012?
Make the answer very short. 0.89. What is the ratio of the Agriculture value added per worker (constant 2005 US$) in Bahamas in 2010 to that in 2011?
Provide a succinct answer. 0.87. What is the ratio of the Agriculture value added per worker (constant 2005 US$) in Belarus in 2010 to that in 2011?
Make the answer very short. 0.9. What is the ratio of the Agriculture value added per worker (constant 2005 US$) in Togo in 2010 to that in 2011?
Keep it short and to the point. 0.97. What is the ratio of the Agriculture value added per worker (constant 2005 US$) in Bahamas in 2010 to that in 2012?
Offer a very short reply. 0.83. What is the ratio of the Agriculture value added per worker (constant 2005 US$) in Belarus in 2010 to that in 2012?
Your answer should be very brief. 0.81. What is the ratio of the Agriculture value added per worker (constant 2005 US$) of Togo in 2010 to that in 2012?
Make the answer very short. 0.89. What is the ratio of the Agriculture value added per worker (constant 2005 US$) in Bahamas in 2011 to that in 2012?
Ensure brevity in your answer.  0.96. What is the ratio of the Agriculture value added per worker (constant 2005 US$) in Belarus in 2011 to that in 2012?
Your answer should be very brief. 0.9. What is the ratio of the Agriculture value added per worker (constant 2005 US$) of Togo in 2011 to that in 2012?
Your answer should be very brief. 0.92. What is the difference between the highest and the second highest Agriculture value added per worker (constant 2005 US$) in Bahamas?
Offer a very short reply. 1532.5. What is the difference between the highest and the second highest Agriculture value added per worker (constant 2005 US$) of Belarus?
Keep it short and to the point. 889.83. What is the difference between the highest and the second highest Agriculture value added per worker (constant 2005 US$) of Togo?
Provide a succinct answer. 95.32. What is the difference between the highest and the lowest Agriculture value added per worker (constant 2005 US$) of Bahamas?
Your response must be concise. 8888.62. What is the difference between the highest and the lowest Agriculture value added per worker (constant 2005 US$) in Belarus?
Provide a succinct answer. 3673.67. What is the difference between the highest and the lowest Agriculture value added per worker (constant 2005 US$) in Togo?
Provide a short and direct response. 205.68. 